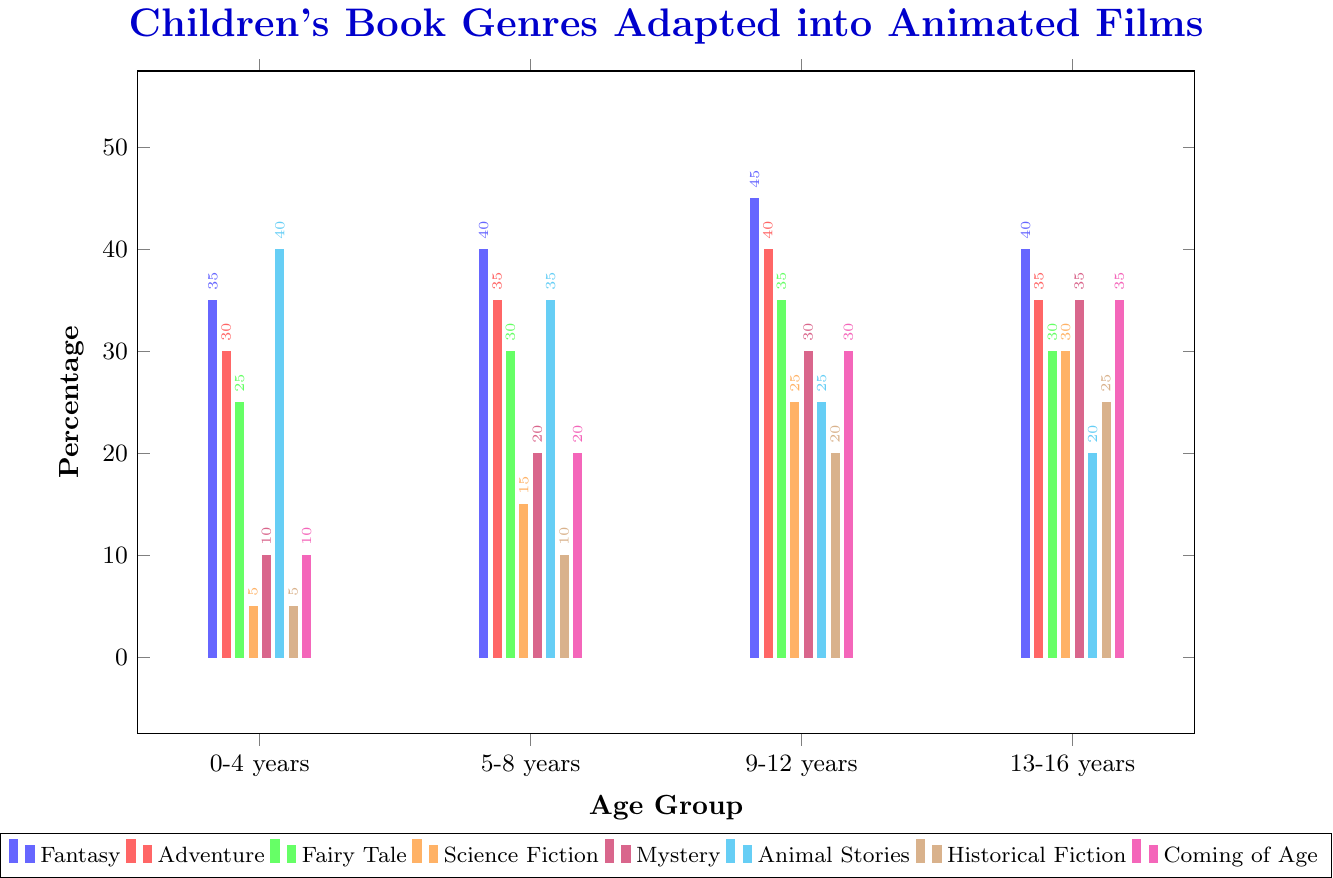What's the most frequently adapted genre for 9-12 years? Look at the heights of the bars for the age group 9-12 years. The tallest bar represents Fantasy with a value of 45%.
Answer: Fantasy Which age group has the highest percentage of Science Fiction adaptations? Compare the heights of the bars representing Science Fiction across all age groups. The tallest one is for 13-16 years with a value of 30%.
Answer: 13-16 years How does the percentage of Animal Stories adaptations change as the age group increases? Note the values of Animal Stories for each age group: 0-4 years (40%), 5-8 years (35%), 9-12 years (25%), and 13-16 years (20%). The percentage decreases as the age group increases.
Answer: Decreases What is the total adaptation percentage for Adventure and Mystery combined for the 9-12 age group? Look at the percentages for Adventure (40%) and Mystery (30%) in the 9-12 age group. Add them together: 40% + 30% = 70%.
Answer: 70% How many genres have a higher adaptation percentage for 5-8 years compared to 0-4 years? Compare the values for each genre between the two age groups. Fantasy (40% vs 35%), Adventure (35% vs 30%), Fairy Tale (30% vs 25%), Science Fiction (15% vs 5%), and Mystery (20% vs 10%) have higher percentages, giving a total of 5 genres.
Answer: 5 genres Which genre shows the most significant increase in adaptation percentage from 0-4 years to 13-16 years? Calculate the difference for each genre between 0-4 years and 13-16 years. Science Fiction shows the largest increase from 5% to 30%, which is a 25% increase.
Answer: Science Fiction What is the average adaptation percentage of Fairy Tales across all age groups? Sum the percentages of Fairy Tales for all age groups (25%, 30%, 35%, 30%) and divide by the number of age groups (4). (25 + 30 + 35 + 30) / 4 = 30%.
Answer: 30% 